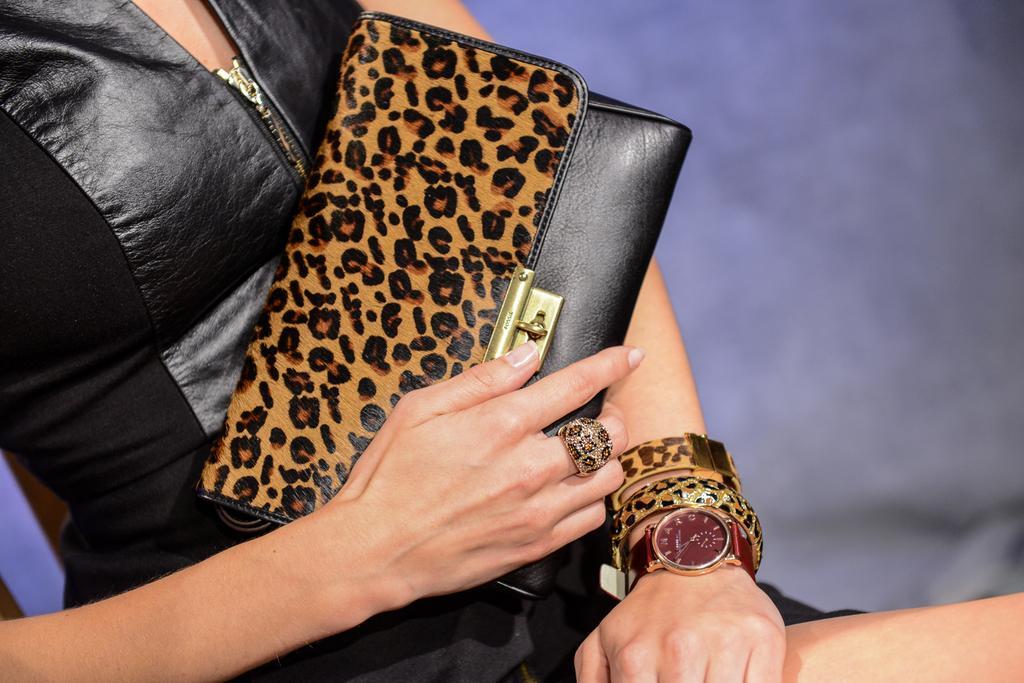Could you give a brief overview of what you see in this image? In this image we can see a lady holding a purse. She is wearing a black dress. 